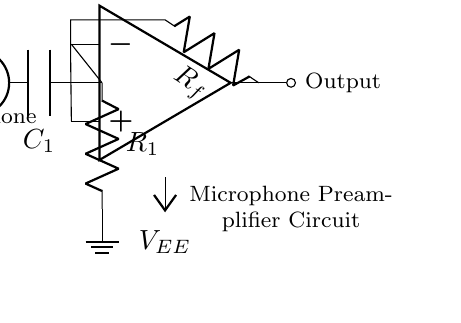What type of circuit is this? This is a microphone preamplifier circuit, which is designed to amplify low-level audio signals from a microphone.
Answer: Microphone preamplifier What components are used in the feedback network? The feedback network consists of a resistor labeled R_f, which connects the output of the operational amplifier back to its inverting input.
Answer: Resistor R_f What is the purpose of the coupling capacitor? The coupling capacitor, labeled C_1, serves to block any DC component from the microphone signal while allowing the AC audio signal to pass through, ensuring accurate amplification.
Answer: To block DC signals What are the power supply voltages in this circuit? The circuit uses two power supply voltages: V_CC for the positive power supply and V_EE for the negative power supply. These voltages are essential for the operational amplifier to function correctly.
Answer: V_CC and V_EE How does the non-inverting input of the operational amplifier connect in this circuit? The non-inverting input of the operational amplifier connects to the output of the input resistor R_1, which is tied to the coupling capacitor from the microphone signal. This connection allows the operational amplifier to receive the amplified signal.
Answer: To input resistor R_1 What role does the ground connection serve in this circuit? The ground connection provides a common reference point for the circuit, ensuring stable operation and proper biasing of components involved, particularly the input resistor R_1.
Answer: Common reference point What will happen to the signal if the feedback resistor R_f is increased? If the feedback resistor R_f is increased, the gain of the operational amplifier will increase, resulting in a greater amplification of the input signal, but may also introduce distortion if excessive.
Answer: Gain increases 